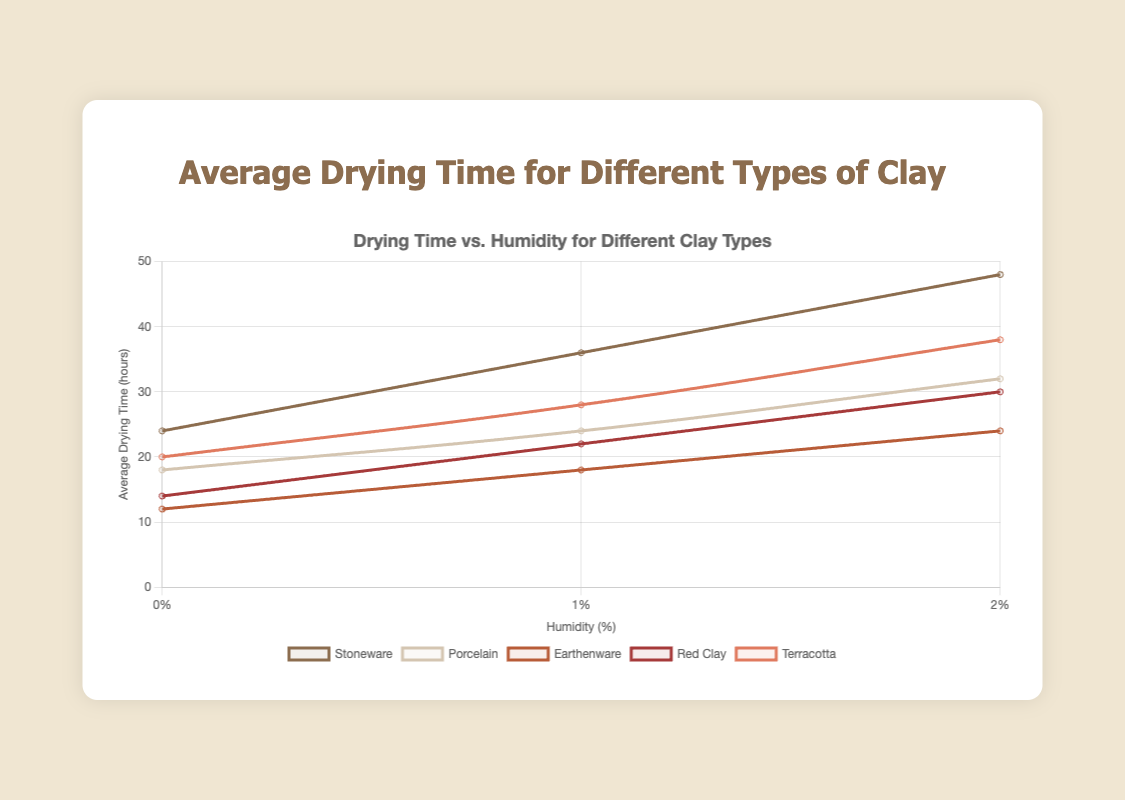Which clay type has the shortest average drying time at 70% humidity? At 70% humidity, Earthenware has the shortest average drying time of 24 hours compared to other types of clay which range from 30 to 48 hours.
Answer: Earthenware Which clay type shows the largest increase in drying time between 30% and 70% humidity? The Stoneware type increases from 24 hours at 30% humidity to 48 hours at 70% humidity, making a 24-hour increase.
Answer: Stoneware How much longer does Stoneware take to dry at 50% humidity compared to 30% humidity? Stoneware takes 36 hours at 50% humidity and 24 hours at 30% humidity. The difference is 36 - 24 = 12 hours.
Answer: 12 hours Which two clay types have the smallest difference in drying time at 50% humidity? Porcelain and Red Clay have drying times of 24 and 22 hours respectively at 50% humidity, making the difference 24 - 22 = 2 hours.
Answer: Porcelain and Red Clay What is the average drying time of Terracotta across the humidity levels? The drying times for Terracotta are 20, 28, and 38 hours at 30%, 50%, and 70% humidity respectively. The average is (20 + 28 + 38) / 3 = 29 hours.
Answer: 29 hours At which humidity level do all clay types have the highest average drying time? At 70% humidity, the drying times range from 24 to 48 hours, which are the highest values for all clay types compared to 30% and 50% humidity.
Answer: 70% Between which two humidity levels does Earthenware show a constant increase in drying time? Earthenware shows an increase from 12 hours at 30% humidity to 18 hours at 50% humidity (increase of 6 hours), and from 18 hours at 50% humidity to 24 hours at 70% humidity (another increase of 6 hours).
Answer: 30% to 50% and 50% to 70% Which clay type has a drying time of 32 hours at 70% humidity? Porcelain has a drying time of 32 hours at 70% humidity as indicated by the data points.
Answer: Porcelain How much longer does Red Clay take to dry at 70% humidity compared to Earthenware at the same humidity? Red Clay takes 30 hours at 70% humidity whereas Earthenware takes 24 hours. The difference is 30 - 24 = 6 hours.
Answer: 6 hours Which clay type is represented by a line that is colored with the darkest shade? By examining the lines’ colors, Stoneware is represented by the darkest shade on the plot.
Answer: Stoneware 